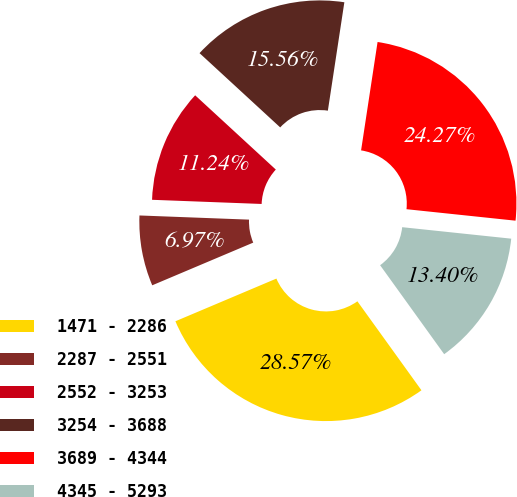<chart> <loc_0><loc_0><loc_500><loc_500><pie_chart><fcel>1471 - 2286<fcel>2287 - 2551<fcel>2552 - 3253<fcel>3254 - 3688<fcel>3689 - 4344<fcel>4345 - 5293<nl><fcel>28.57%<fcel>6.97%<fcel>11.24%<fcel>15.56%<fcel>24.27%<fcel>13.4%<nl></chart> 